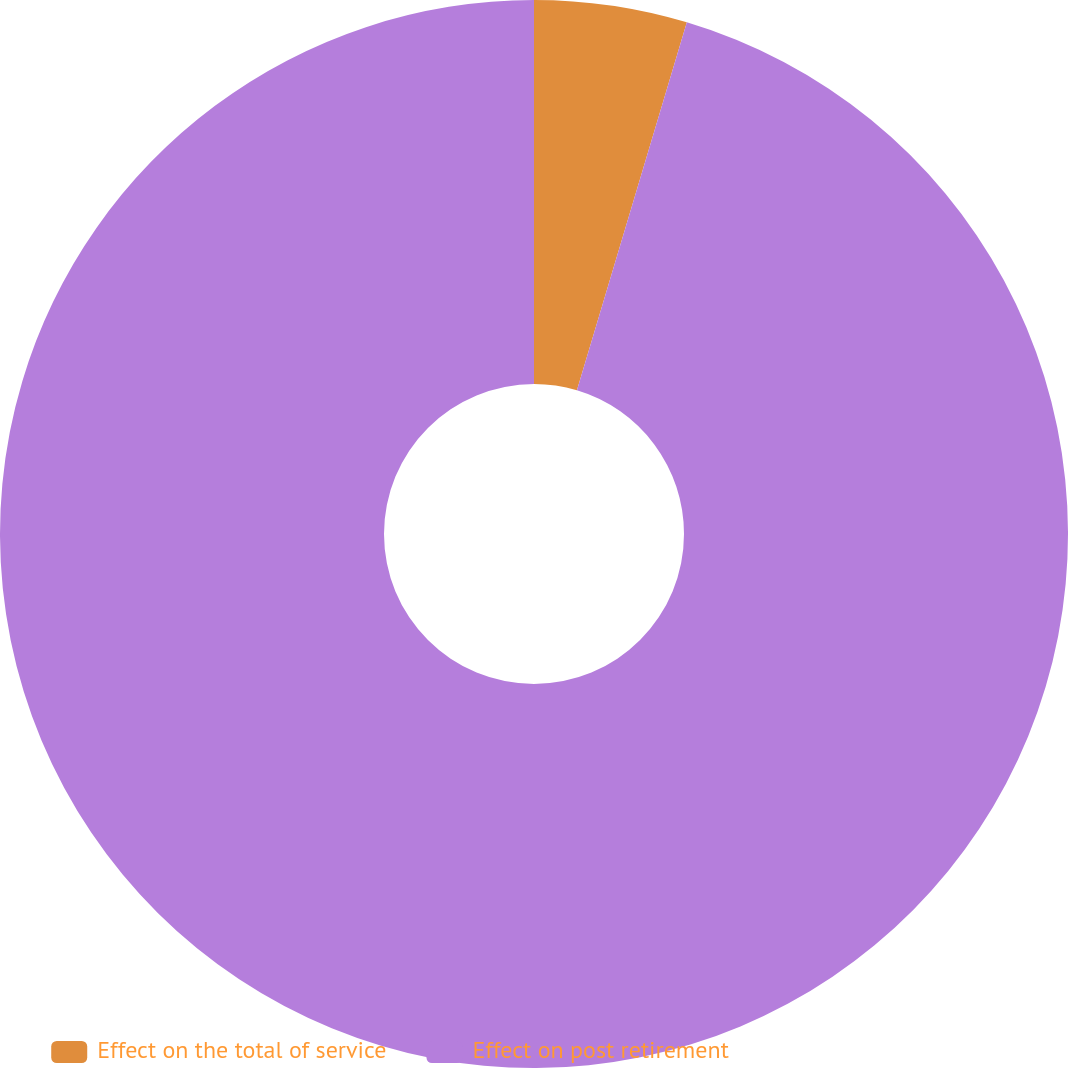<chart> <loc_0><loc_0><loc_500><loc_500><pie_chart><fcel>Effect on the total of service<fcel>Effect on post retirement<nl><fcel>4.62%<fcel>95.38%<nl></chart> 